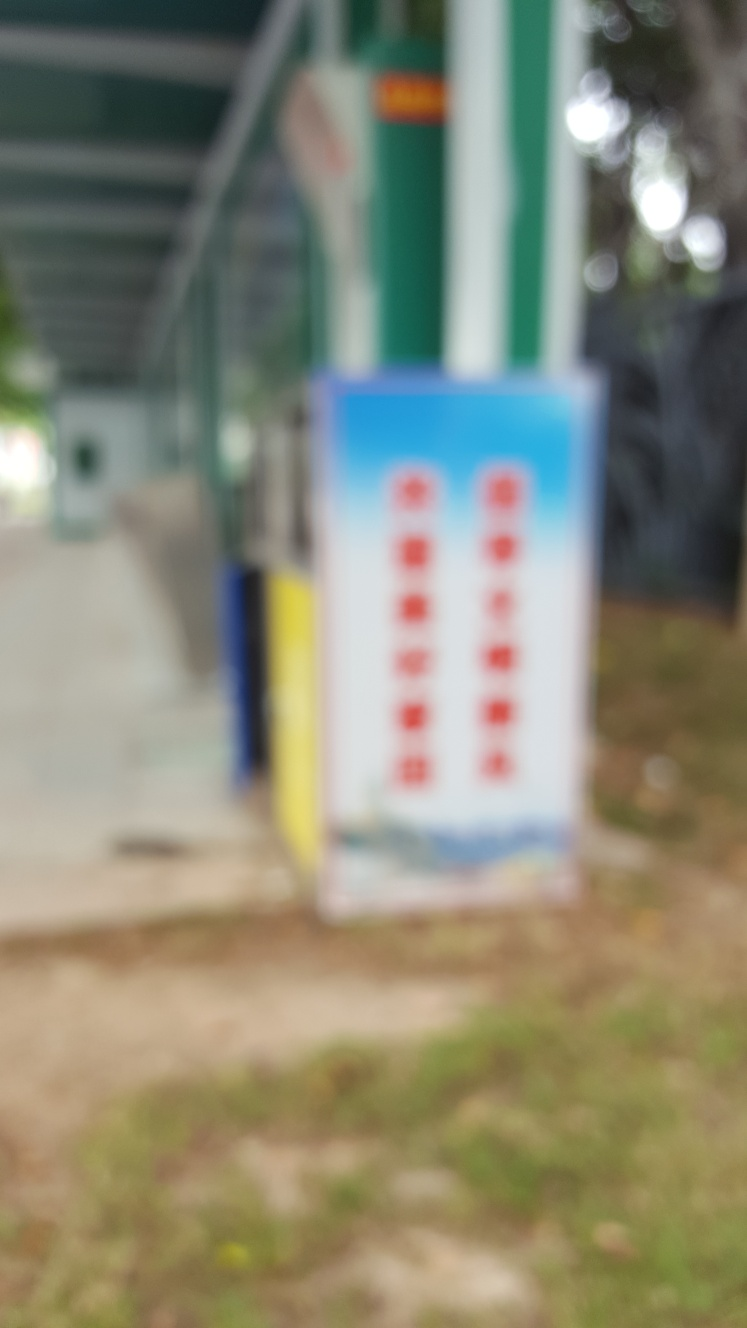How is the subject of the photograph?
 blurry 